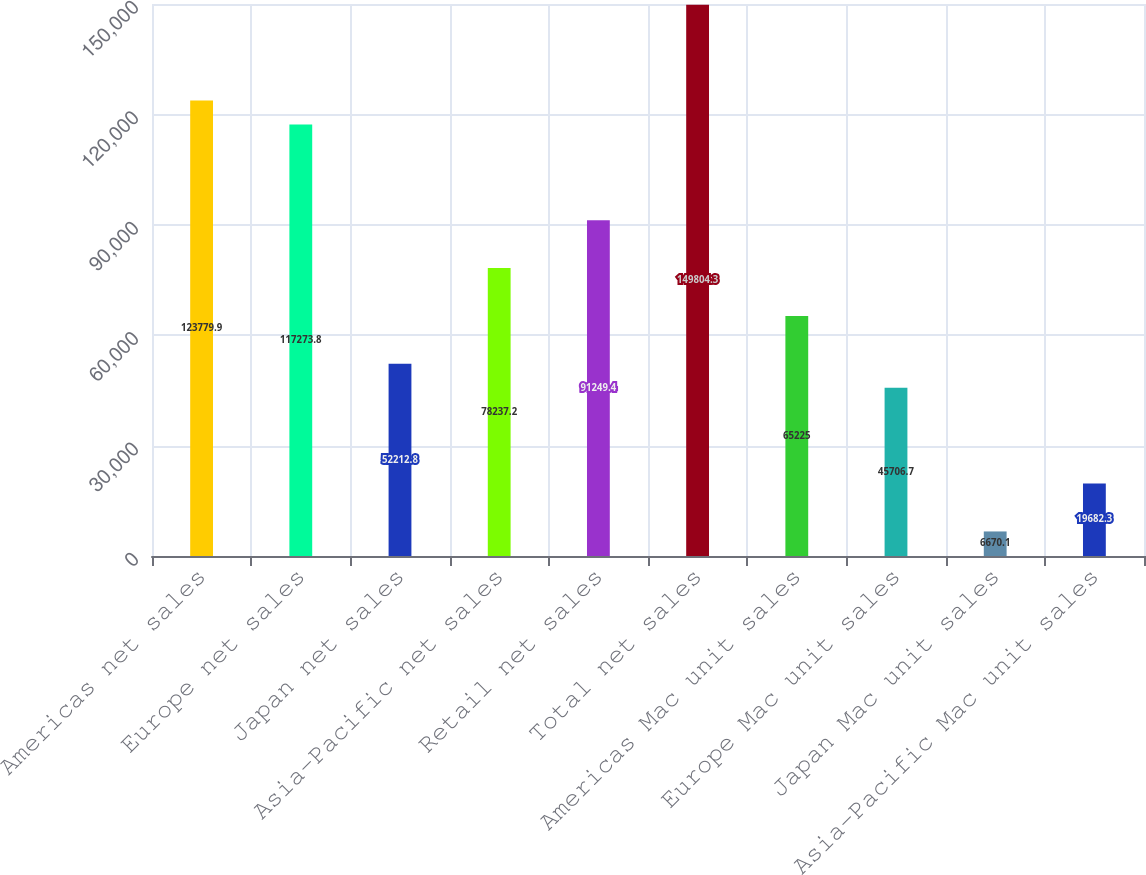<chart> <loc_0><loc_0><loc_500><loc_500><bar_chart><fcel>Americas net sales<fcel>Europe net sales<fcel>Japan net sales<fcel>Asia-Pacific net sales<fcel>Retail net sales<fcel>Total net sales<fcel>Americas Mac unit sales<fcel>Europe Mac unit sales<fcel>Japan Mac unit sales<fcel>Asia-Pacific Mac unit sales<nl><fcel>123780<fcel>117274<fcel>52212.8<fcel>78237.2<fcel>91249.4<fcel>149804<fcel>65225<fcel>45706.7<fcel>6670.1<fcel>19682.3<nl></chart> 